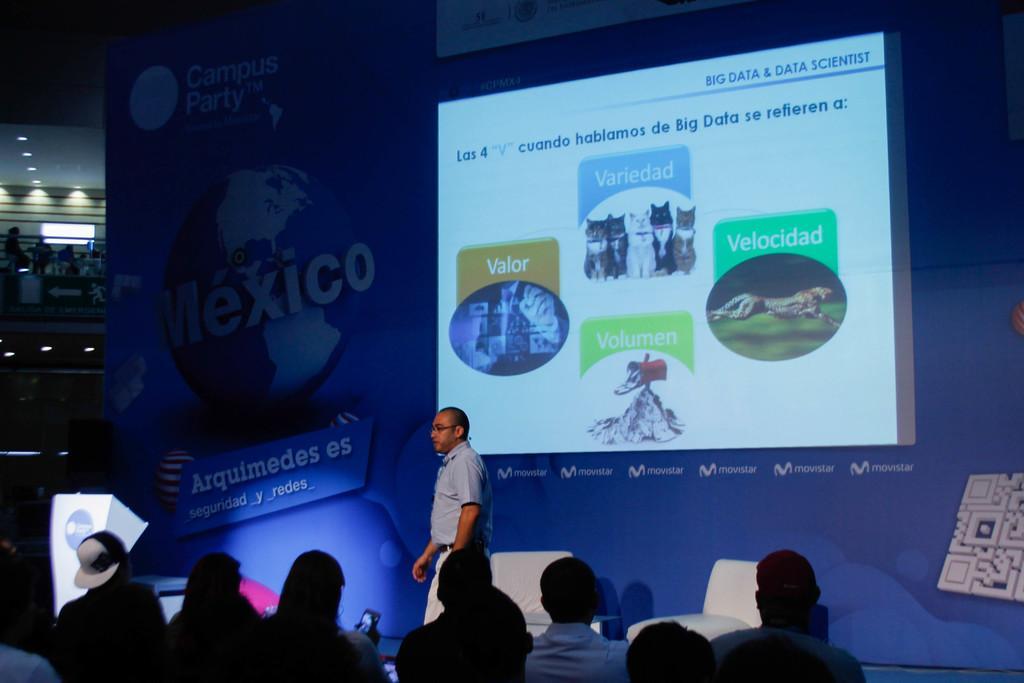How would you summarize this image in a sentence or two? In this image there is a person on the stage, behind the person there are empty chairs, behind the chairs there is a screen and a poster, in front of the person there are a few people. On the left of the image there are a few people sitting in the first floor of the building in front of them there is metal rod balconies and there are lamps, on the stage there is dais. 